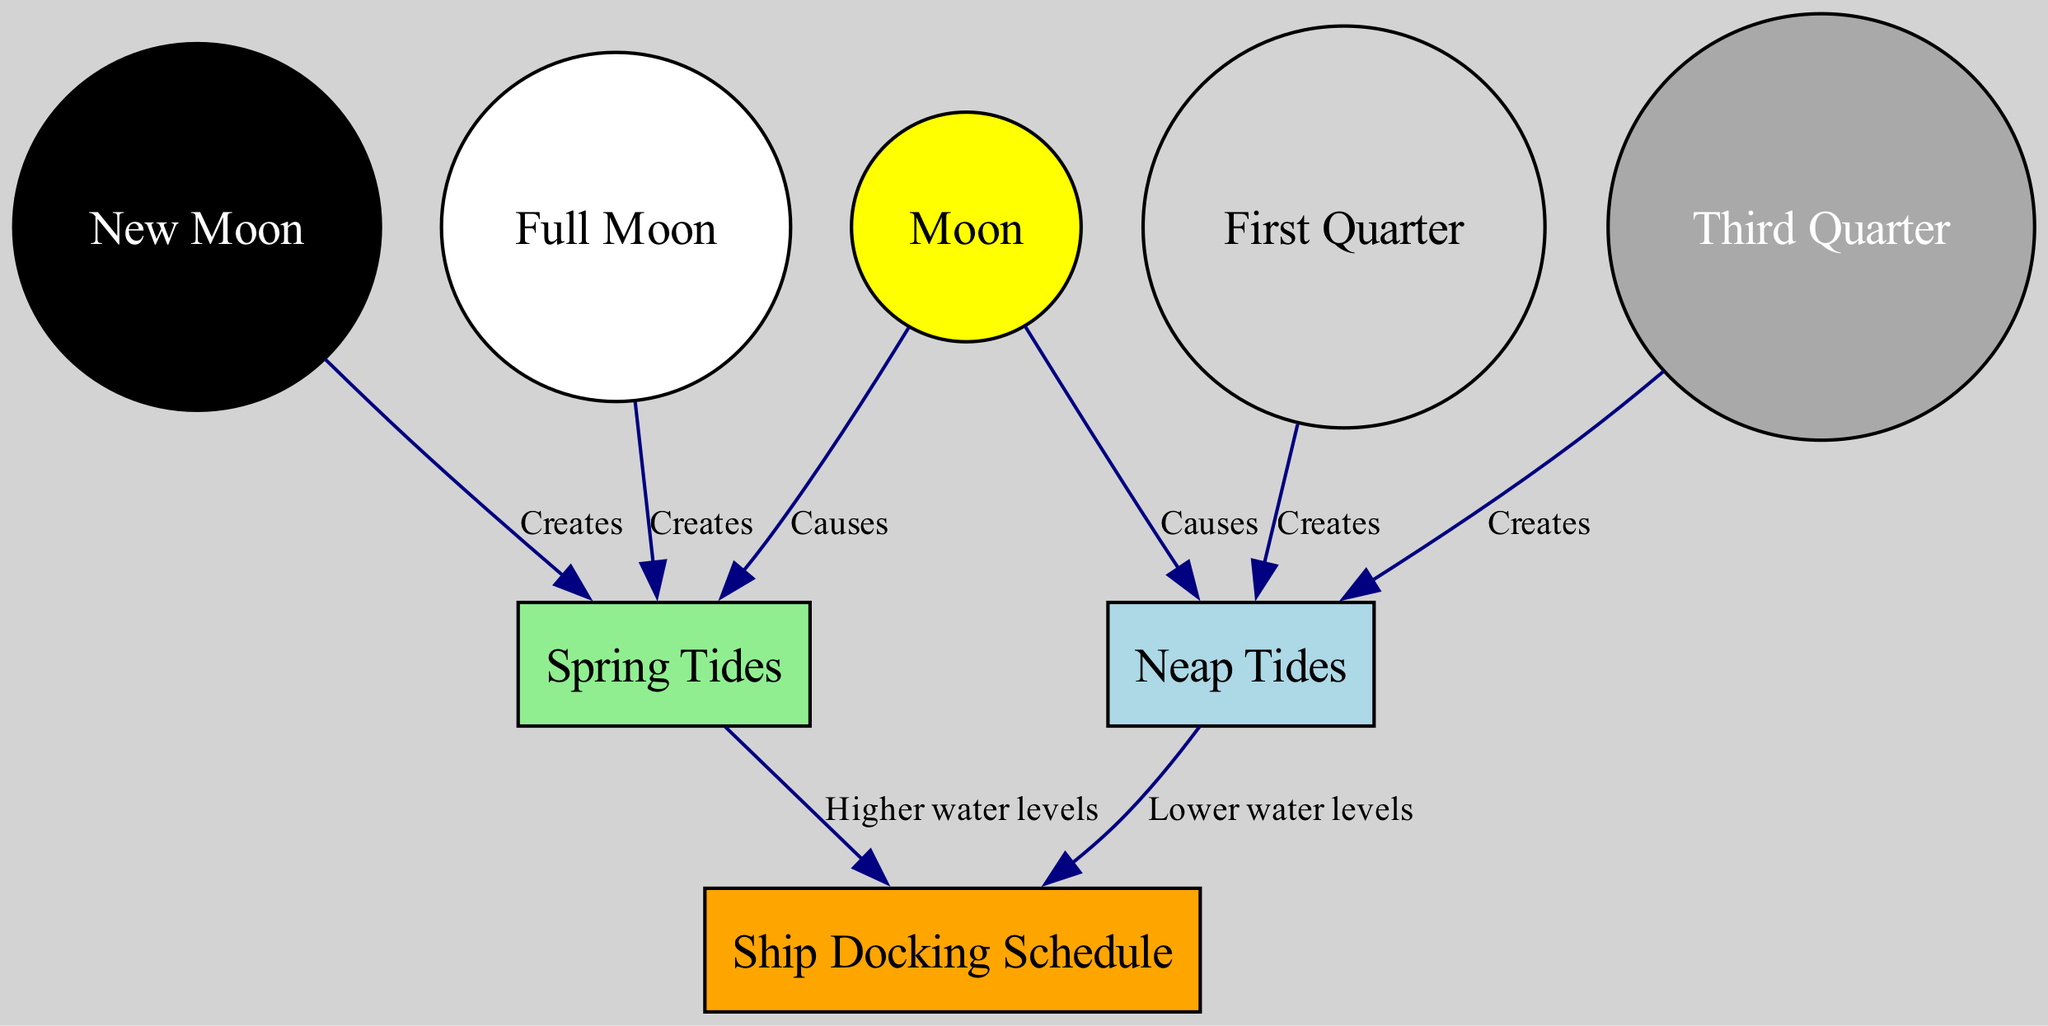what causes neap tides? The diagram shows that neap tides are caused by the Moon, as indicated by the directed edge labeled "Causes" that connects "Moon" to "Neap Tides."
Answer: Moon what creates spring tides? According to the diagram, spring tides are created by both the full moon and the new moon, as illustrated by the edges labeled "Creates" connecting "Full Moon" to "Spring Tides" and "New Moon" to "Spring Tides."
Answer: Full Moon and New Moon how many nodes are in the diagram? By counting the nodes listed in the diagram, there are eight distinct nodes: Moon, Neap Tides, Spring Tides, Full Moon, New Moon, First Quarter, Third Quarter, and Ship Docking Schedule.
Answer: 8 what effect do spring tides have on the docking schedule? The diagram indicates that spring tides lead to higher water levels, which impacts the docking schedule as shown by the directed edge from "Spring Tides" to "Ship Docking Schedule" labeled "Higher water levels."
Answer: Higher water levels which phase of the moon causes lower water levels? The diagram indicates that lower water levels result from neap tides, which are created by the first quarter and third quarter phases of the moon, as shown in the relationships between "First Quarter," "Third Quarter," and "Neap Tides."
Answer: Neap Tides 